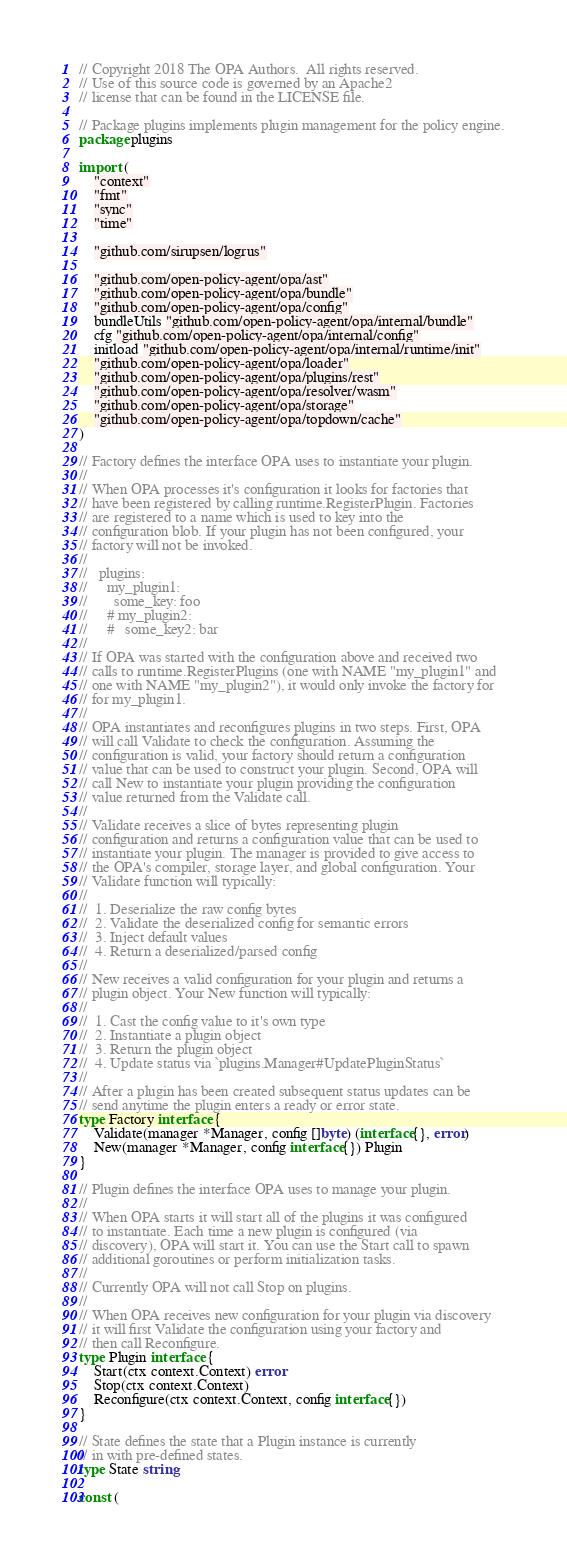<code> <loc_0><loc_0><loc_500><loc_500><_Go_>// Copyright 2018 The OPA Authors.  All rights reserved.
// Use of this source code is governed by an Apache2
// license that can be found in the LICENSE file.

// Package plugins implements plugin management for the policy engine.
package plugins

import (
	"context"
	"fmt"
	"sync"
	"time"

	"github.com/sirupsen/logrus"

	"github.com/open-policy-agent/opa/ast"
	"github.com/open-policy-agent/opa/bundle"
	"github.com/open-policy-agent/opa/config"
	bundleUtils "github.com/open-policy-agent/opa/internal/bundle"
	cfg "github.com/open-policy-agent/opa/internal/config"
	initload "github.com/open-policy-agent/opa/internal/runtime/init"
	"github.com/open-policy-agent/opa/loader"
	"github.com/open-policy-agent/opa/plugins/rest"
	"github.com/open-policy-agent/opa/resolver/wasm"
	"github.com/open-policy-agent/opa/storage"
	"github.com/open-policy-agent/opa/topdown/cache"
)

// Factory defines the interface OPA uses to instantiate your plugin.
//
// When OPA processes it's configuration it looks for factories that
// have been registered by calling runtime.RegisterPlugin. Factories
// are registered to a name which is used to key into the
// configuration blob. If your plugin has not been configured, your
// factory will not be invoked.
//
//   plugins:
//     my_plugin1:
//       some_key: foo
//     # my_plugin2:
//     #   some_key2: bar
//
// If OPA was started with the configuration above and received two
// calls to runtime.RegisterPlugins (one with NAME "my_plugin1" and
// one with NAME "my_plugin2"), it would only invoke the factory for
// for my_plugin1.
//
// OPA instantiates and reconfigures plugins in two steps. First, OPA
// will call Validate to check the configuration. Assuming the
// configuration is valid, your factory should return a configuration
// value that can be used to construct your plugin. Second, OPA will
// call New to instantiate your plugin providing the configuration
// value returned from the Validate call.
//
// Validate receives a slice of bytes representing plugin
// configuration and returns a configuration value that can be used to
// instantiate your plugin. The manager is provided to give access to
// the OPA's compiler, storage layer, and global configuration. Your
// Validate function will typically:
//
//  1. Deserialize the raw config bytes
//  2. Validate the deserialized config for semantic errors
//  3. Inject default values
//  4. Return a deserialized/parsed config
//
// New receives a valid configuration for your plugin and returns a
// plugin object. Your New function will typically:
//
//  1. Cast the config value to it's own type
//  2. Instantiate a plugin object
//  3. Return the plugin object
//  4. Update status via `plugins.Manager#UpdatePluginStatus`
//
// After a plugin has been created subsequent status updates can be
// send anytime the plugin enters a ready or error state.
type Factory interface {
	Validate(manager *Manager, config []byte) (interface{}, error)
	New(manager *Manager, config interface{}) Plugin
}

// Plugin defines the interface OPA uses to manage your plugin.
//
// When OPA starts it will start all of the plugins it was configured
// to instantiate. Each time a new plugin is configured (via
// discovery), OPA will start it. You can use the Start call to spawn
// additional goroutines or perform initialization tasks.
//
// Currently OPA will not call Stop on plugins.
//
// When OPA receives new configuration for your plugin via discovery
// it will first Validate the configuration using your factory and
// then call Reconfigure.
type Plugin interface {
	Start(ctx context.Context) error
	Stop(ctx context.Context)
	Reconfigure(ctx context.Context, config interface{})
}

// State defines the state that a Plugin instance is currently
// in with pre-defined states.
type State string

const (</code> 